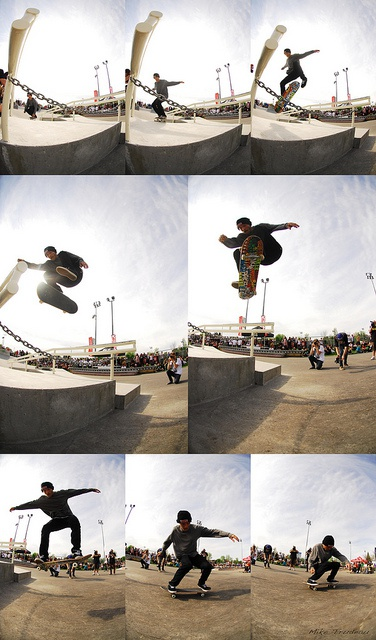Describe the objects in this image and their specific colors. I can see people in darkgray, black, gray, and white tones, people in darkgray, black, gray, white, and maroon tones, people in darkgray, black, white, gray, and maroon tones, people in darkgray, black, maroon, and gray tones, and people in darkgray, black, gray, and maroon tones in this image. 